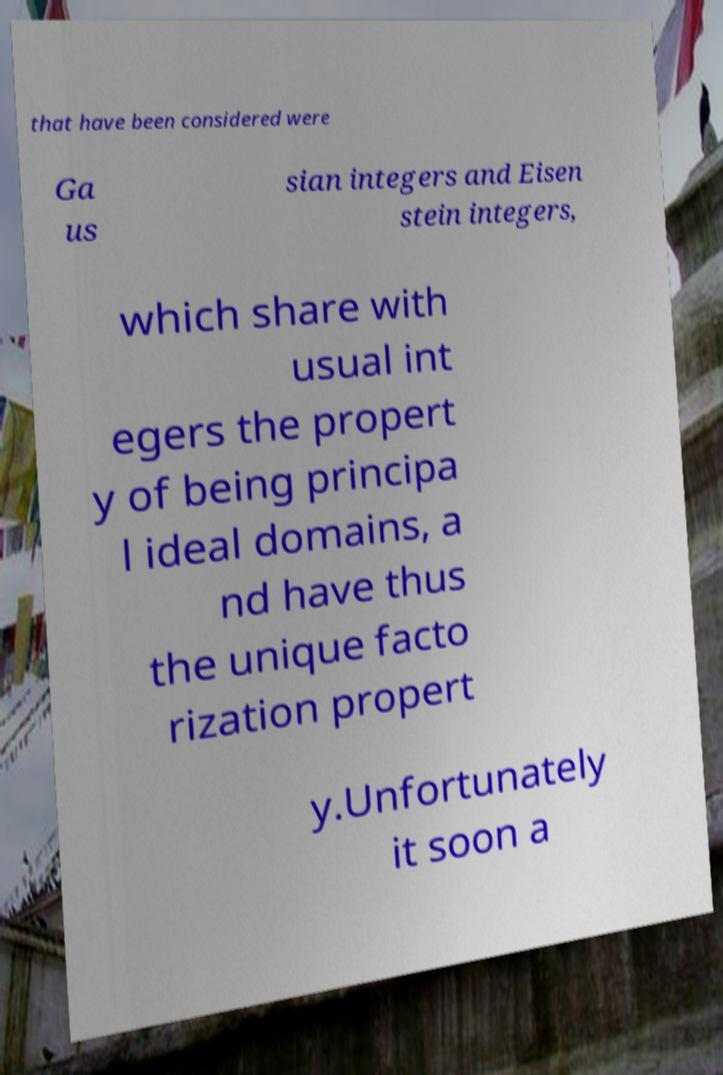Please identify and transcribe the text found in this image. that have been considered were Ga us sian integers and Eisen stein integers, which share with usual int egers the propert y of being principa l ideal domains, a nd have thus the unique facto rization propert y.Unfortunately it soon a 